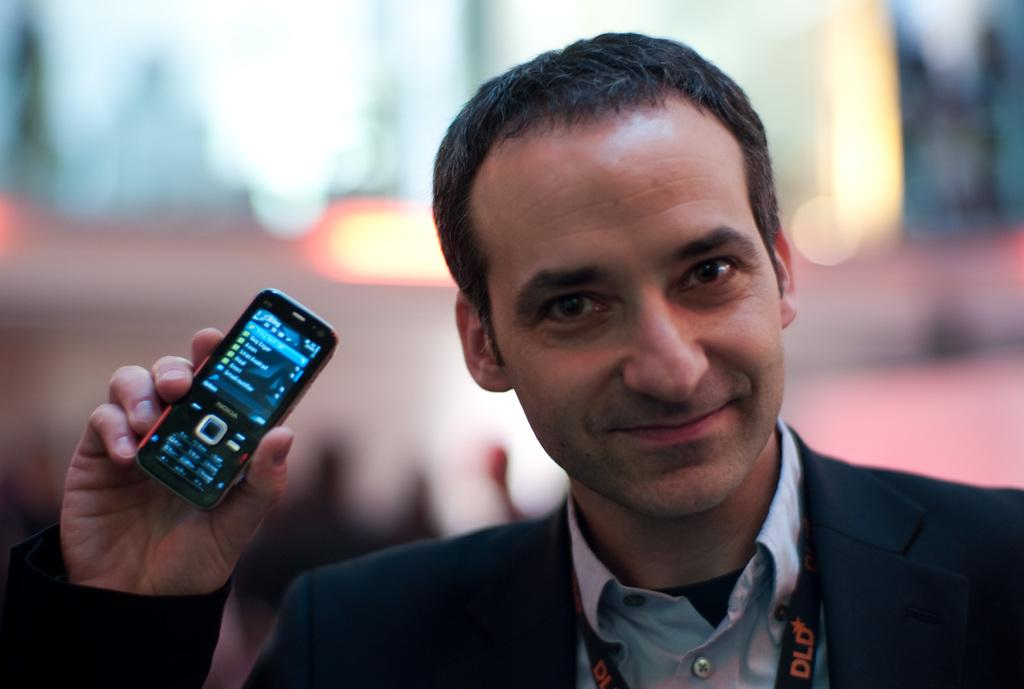Who is present in the image? There is a man in the image. What is the man wearing? The man is wearing a blazer. What is the man holding in his hand? The man is holding a mobile in his hand. What is the man's facial expression? The man is smiling. What can be seen in the background of the image? There are lights visible in the background of the image. How would you describe the background of the image? The background is blurry. What type of quill is the man using to write in the image? There is no quill present in the image; the man is holding a mobile in his hand. 